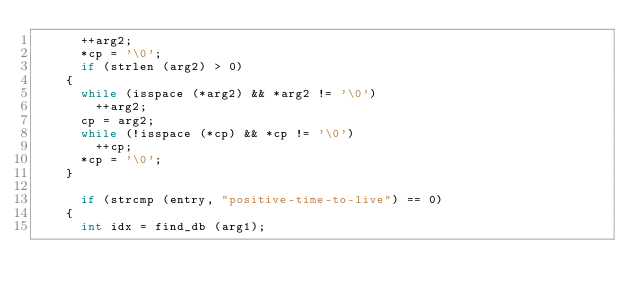<code> <loc_0><loc_0><loc_500><loc_500><_C_>      ++arg2;
      *cp = '\0';
      if (strlen (arg2) > 0)
	{
	  while (isspace (*arg2) && *arg2 != '\0')
	    ++arg2;
	  cp = arg2;
	  while (!isspace (*cp) && *cp != '\0')
	    ++cp;
	  *cp = '\0';
	}

      if (strcmp (entry, "positive-time-to-live") == 0)
	{
	  int idx = find_db (arg1);</code> 